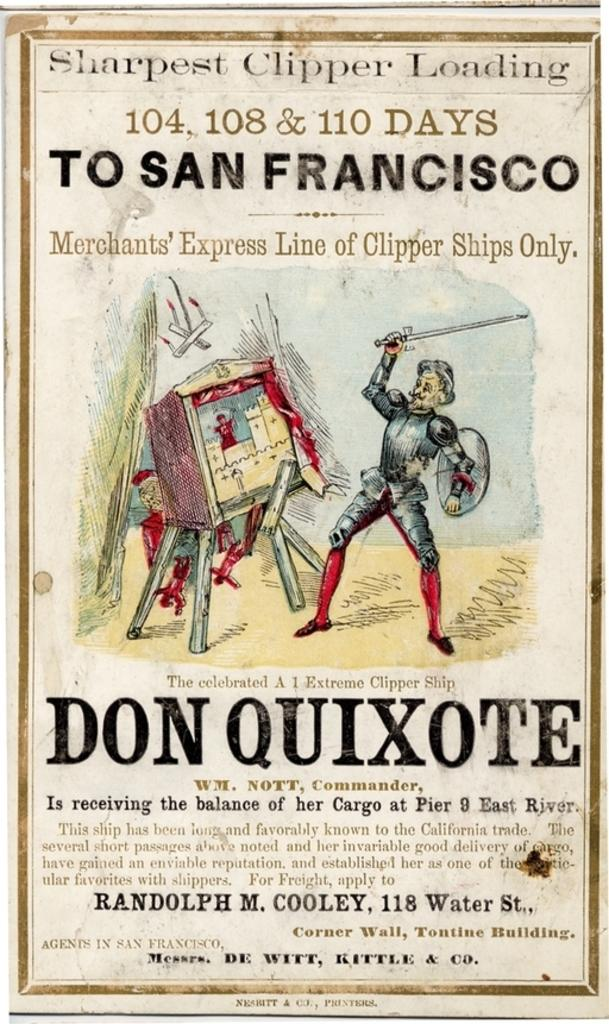<image>
Present a compact description of the photo's key features. Poster showing a man fencing with the title "Sharpest Clipper Loading". 